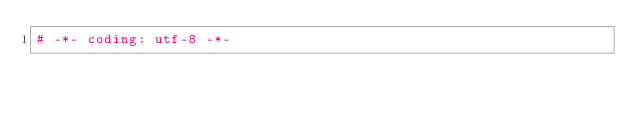<code> <loc_0><loc_0><loc_500><loc_500><_Python_># -*- coding: utf-8 -*-</code> 